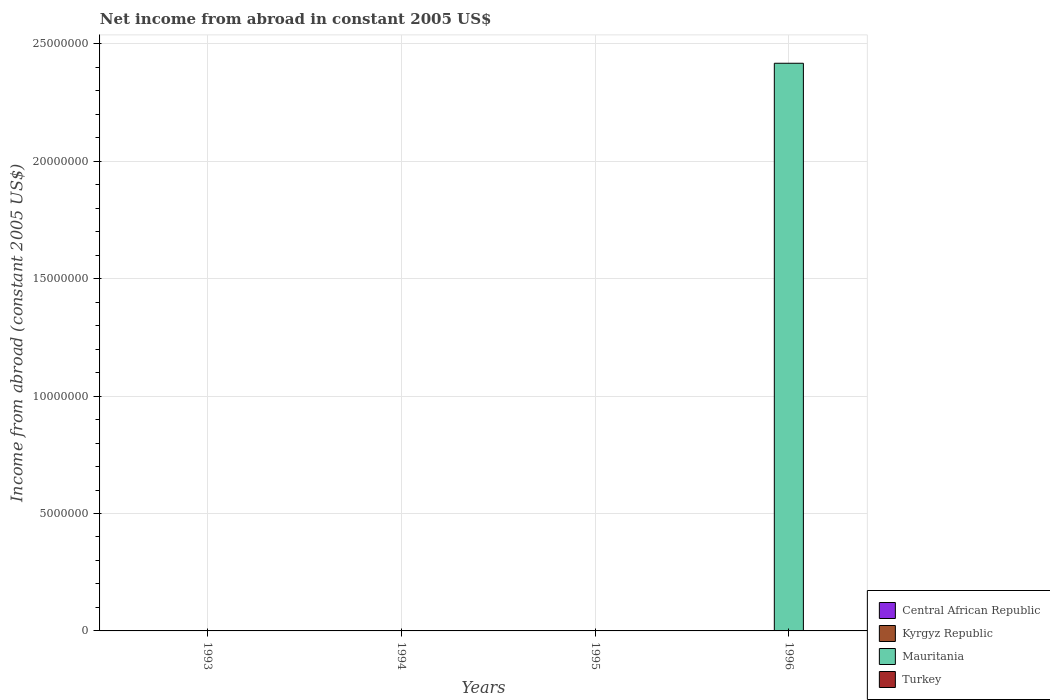How many different coloured bars are there?
Your response must be concise. 1. Are the number of bars per tick equal to the number of legend labels?
Ensure brevity in your answer.  No. What is the label of the 2nd group of bars from the left?
Offer a terse response. 1994. What is the net income from abroad in Mauritania in 1994?
Give a very brief answer. 0. Across all years, what is the maximum net income from abroad in Mauritania?
Your response must be concise. 2.42e+07. Across all years, what is the minimum net income from abroad in Turkey?
Your answer should be compact. 0. In which year was the net income from abroad in Mauritania maximum?
Offer a very short reply. 1996. What is the total net income from abroad in Mauritania in the graph?
Keep it short and to the point. 2.42e+07. What is the difference between the net income from abroad in Mauritania in 1996 and the net income from abroad in Kyrgyz Republic in 1994?
Your answer should be compact. 2.42e+07. What is the average net income from abroad in Mauritania per year?
Your answer should be very brief. 6.04e+06. In how many years, is the net income from abroad in Mauritania greater than 9000000 US$?
Keep it short and to the point. 1. What is the difference between the highest and the lowest net income from abroad in Mauritania?
Provide a succinct answer. 2.42e+07. In how many years, is the net income from abroad in Turkey greater than the average net income from abroad in Turkey taken over all years?
Make the answer very short. 0. Is it the case that in every year, the sum of the net income from abroad in Turkey and net income from abroad in Mauritania is greater than the sum of net income from abroad in Kyrgyz Republic and net income from abroad in Central African Republic?
Provide a succinct answer. No. Is it the case that in every year, the sum of the net income from abroad in Mauritania and net income from abroad in Central African Republic is greater than the net income from abroad in Turkey?
Offer a very short reply. No. How many bars are there?
Your response must be concise. 1. What is the difference between two consecutive major ticks on the Y-axis?
Your answer should be compact. 5.00e+06. Does the graph contain any zero values?
Give a very brief answer. Yes. Where does the legend appear in the graph?
Your response must be concise. Bottom right. What is the title of the graph?
Offer a terse response. Net income from abroad in constant 2005 US$. What is the label or title of the Y-axis?
Ensure brevity in your answer.  Income from abroad (constant 2005 US$). What is the Income from abroad (constant 2005 US$) in Central African Republic in 1993?
Provide a short and direct response. 0. What is the Income from abroad (constant 2005 US$) of Mauritania in 1993?
Your response must be concise. 0. What is the Income from abroad (constant 2005 US$) of Turkey in 1993?
Your answer should be very brief. 0. What is the Income from abroad (constant 2005 US$) in Central African Republic in 1994?
Your answer should be compact. 0. What is the Income from abroad (constant 2005 US$) in Kyrgyz Republic in 1994?
Provide a short and direct response. 0. What is the Income from abroad (constant 2005 US$) in Mauritania in 1994?
Make the answer very short. 0. What is the Income from abroad (constant 2005 US$) of Turkey in 1994?
Provide a succinct answer. 0. What is the Income from abroad (constant 2005 US$) of Turkey in 1995?
Your answer should be very brief. 0. What is the Income from abroad (constant 2005 US$) of Mauritania in 1996?
Ensure brevity in your answer.  2.42e+07. Across all years, what is the maximum Income from abroad (constant 2005 US$) of Mauritania?
Your answer should be compact. 2.42e+07. Across all years, what is the minimum Income from abroad (constant 2005 US$) in Mauritania?
Your response must be concise. 0. What is the total Income from abroad (constant 2005 US$) in Mauritania in the graph?
Offer a terse response. 2.42e+07. What is the average Income from abroad (constant 2005 US$) in Central African Republic per year?
Ensure brevity in your answer.  0. What is the average Income from abroad (constant 2005 US$) of Mauritania per year?
Provide a short and direct response. 6.04e+06. What is the difference between the highest and the lowest Income from abroad (constant 2005 US$) in Mauritania?
Offer a very short reply. 2.42e+07. 